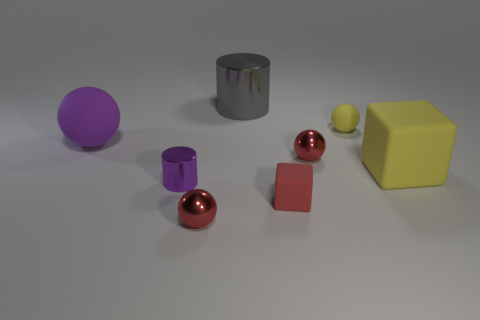Add 1 gray objects. How many objects exist? 9 Subtract all cubes. How many objects are left? 6 Subtract all yellow rubber balls. Subtract all brown metal objects. How many objects are left? 7 Add 1 yellow things. How many yellow things are left? 3 Add 4 yellow metal objects. How many yellow metal objects exist? 4 Subtract 0 brown cylinders. How many objects are left? 8 